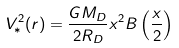<formula> <loc_0><loc_0><loc_500><loc_500>V _ { * } ^ { 2 } ( r ) = \frac { G M _ { D } } { 2 R _ { D } } x ^ { 2 } B \left ( \frac { x } { 2 } \right )</formula> 